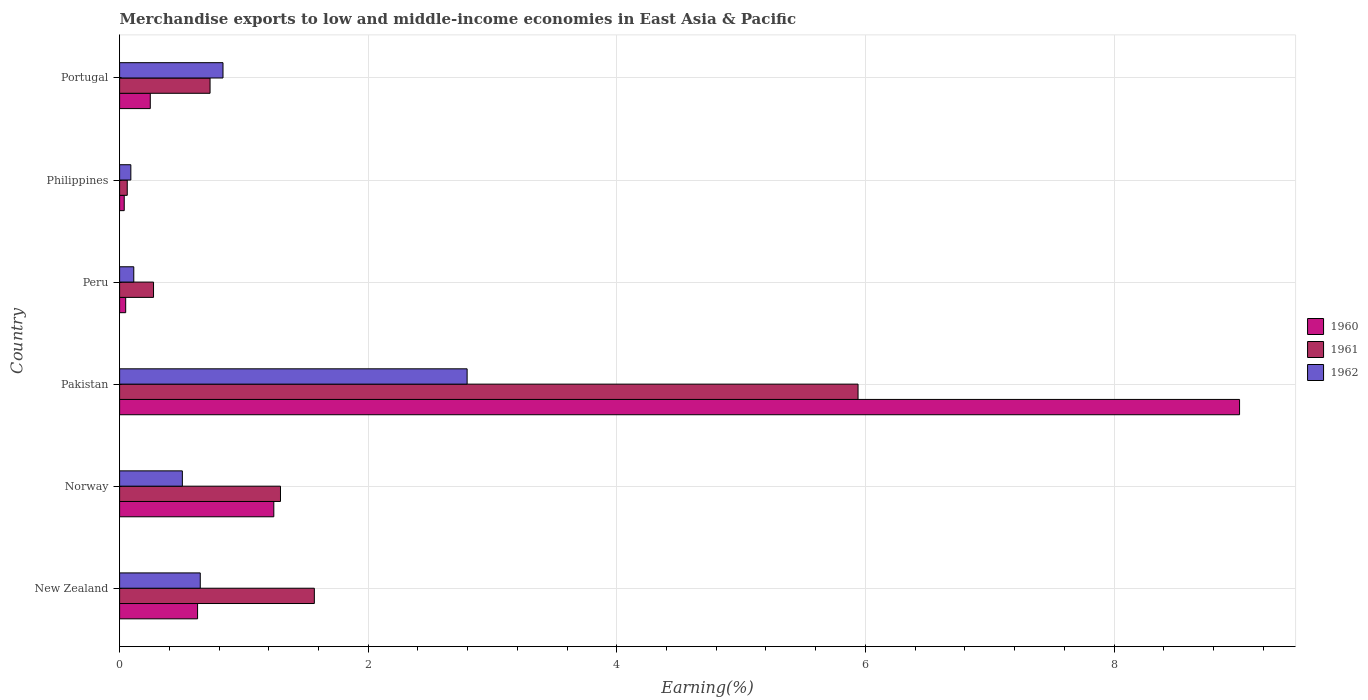How many groups of bars are there?
Give a very brief answer. 6. Are the number of bars on each tick of the Y-axis equal?
Offer a very short reply. Yes. How many bars are there on the 2nd tick from the bottom?
Give a very brief answer. 3. What is the label of the 1st group of bars from the top?
Your answer should be compact. Portugal. In how many cases, is the number of bars for a given country not equal to the number of legend labels?
Your response must be concise. 0. What is the percentage of amount earned from merchandise exports in 1960 in Philippines?
Offer a terse response. 0.04. Across all countries, what is the maximum percentage of amount earned from merchandise exports in 1960?
Provide a short and direct response. 9.01. Across all countries, what is the minimum percentage of amount earned from merchandise exports in 1960?
Provide a succinct answer. 0.04. In which country was the percentage of amount earned from merchandise exports in 1960 maximum?
Provide a short and direct response. Pakistan. In which country was the percentage of amount earned from merchandise exports in 1960 minimum?
Keep it short and to the point. Philippines. What is the total percentage of amount earned from merchandise exports in 1960 in the graph?
Offer a terse response. 11.21. What is the difference between the percentage of amount earned from merchandise exports in 1960 in Pakistan and that in Portugal?
Ensure brevity in your answer.  8.76. What is the difference between the percentage of amount earned from merchandise exports in 1960 in Norway and the percentage of amount earned from merchandise exports in 1961 in Portugal?
Offer a terse response. 0.51. What is the average percentage of amount earned from merchandise exports in 1961 per country?
Your response must be concise. 1.64. What is the difference between the percentage of amount earned from merchandise exports in 1961 and percentage of amount earned from merchandise exports in 1962 in Norway?
Your response must be concise. 0.79. What is the ratio of the percentage of amount earned from merchandise exports in 1961 in Pakistan to that in Peru?
Keep it short and to the point. 21.77. Is the percentage of amount earned from merchandise exports in 1961 in New Zealand less than that in Portugal?
Offer a terse response. No. Is the difference between the percentage of amount earned from merchandise exports in 1961 in Norway and Portugal greater than the difference between the percentage of amount earned from merchandise exports in 1962 in Norway and Portugal?
Your response must be concise. Yes. What is the difference between the highest and the second highest percentage of amount earned from merchandise exports in 1961?
Your response must be concise. 4.37. What is the difference between the highest and the lowest percentage of amount earned from merchandise exports in 1960?
Your response must be concise. 8.97. In how many countries, is the percentage of amount earned from merchandise exports in 1962 greater than the average percentage of amount earned from merchandise exports in 1962 taken over all countries?
Your response must be concise. 2. Is the sum of the percentage of amount earned from merchandise exports in 1960 in Peru and Philippines greater than the maximum percentage of amount earned from merchandise exports in 1962 across all countries?
Provide a succinct answer. No. What does the 1st bar from the top in Pakistan represents?
Provide a short and direct response. 1962. Is it the case that in every country, the sum of the percentage of amount earned from merchandise exports in 1961 and percentage of amount earned from merchandise exports in 1960 is greater than the percentage of amount earned from merchandise exports in 1962?
Give a very brief answer. Yes. How many countries are there in the graph?
Ensure brevity in your answer.  6. What is the difference between two consecutive major ticks on the X-axis?
Offer a very short reply. 2. Are the values on the major ticks of X-axis written in scientific E-notation?
Provide a short and direct response. No. What is the title of the graph?
Give a very brief answer. Merchandise exports to low and middle-income economies in East Asia & Pacific. Does "1985" appear as one of the legend labels in the graph?
Ensure brevity in your answer.  No. What is the label or title of the X-axis?
Your answer should be very brief. Earning(%). What is the label or title of the Y-axis?
Your answer should be compact. Country. What is the Earning(%) of 1960 in New Zealand?
Offer a terse response. 0.63. What is the Earning(%) in 1961 in New Zealand?
Offer a very short reply. 1.57. What is the Earning(%) in 1962 in New Zealand?
Provide a short and direct response. 0.65. What is the Earning(%) in 1960 in Norway?
Keep it short and to the point. 1.24. What is the Earning(%) in 1961 in Norway?
Provide a succinct answer. 1.29. What is the Earning(%) of 1962 in Norway?
Make the answer very short. 0.5. What is the Earning(%) in 1960 in Pakistan?
Provide a succinct answer. 9.01. What is the Earning(%) of 1961 in Pakistan?
Your answer should be compact. 5.94. What is the Earning(%) of 1962 in Pakistan?
Your answer should be very brief. 2.8. What is the Earning(%) in 1960 in Peru?
Provide a succinct answer. 0.05. What is the Earning(%) of 1961 in Peru?
Your answer should be very brief. 0.27. What is the Earning(%) of 1962 in Peru?
Your answer should be very brief. 0.11. What is the Earning(%) in 1960 in Philippines?
Ensure brevity in your answer.  0.04. What is the Earning(%) in 1961 in Philippines?
Make the answer very short. 0.06. What is the Earning(%) of 1962 in Philippines?
Give a very brief answer. 0.09. What is the Earning(%) of 1960 in Portugal?
Give a very brief answer. 0.25. What is the Earning(%) of 1961 in Portugal?
Offer a very short reply. 0.73. What is the Earning(%) of 1962 in Portugal?
Provide a succinct answer. 0.83. Across all countries, what is the maximum Earning(%) of 1960?
Your answer should be compact. 9.01. Across all countries, what is the maximum Earning(%) of 1961?
Make the answer very short. 5.94. Across all countries, what is the maximum Earning(%) of 1962?
Ensure brevity in your answer.  2.8. Across all countries, what is the minimum Earning(%) of 1960?
Give a very brief answer. 0.04. Across all countries, what is the minimum Earning(%) of 1961?
Offer a terse response. 0.06. Across all countries, what is the minimum Earning(%) in 1962?
Offer a terse response. 0.09. What is the total Earning(%) in 1960 in the graph?
Make the answer very short. 11.21. What is the total Earning(%) of 1961 in the graph?
Offer a terse response. 9.86. What is the total Earning(%) of 1962 in the graph?
Offer a terse response. 4.99. What is the difference between the Earning(%) in 1960 in New Zealand and that in Norway?
Give a very brief answer. -0.61. What is the difference between the Earning(%) of 1961 in New Zealand and that in Norway?
Your answer should be very brief. 0.27. What is the difference between the Earning(%) of 1962 in New Zealand and that in Norway?
Give a very brief answer. 0.14. What is the difference between the Earning(%) in 1960 in New Zealand and that in Pakistan?
Your response must be concise. -8.38. What is the difference between the Earning(%) of 1961 in New Zealand and that in Pakistan?
Provide a short and direct response. -4.37. What is the difference between the Earning(%) of 1962 in New Zealand and that in Pakistan?
Offer a terse response. -2.15. What is the difference between the Earning(%) in 1960 in New Zealand and that in Peru?
Your answer should be very brief. 0.58. What is the difference between the Earning(%) in 1961 in New Zealand and that in Peru?
Ensure brevity in your answer.  1.29. What is the difference between the Earning(%) in 1962 in New Zealand and that in Peru?
Provide a short and direct response. 0.53. What is the difference between the Earning(%) in 1960 in New Zealand and that in Philippines?
Your answer should be compact. 0.59. What is the difference between the Earning(%) in 1961 in New Zealand and that in Philippines?
Give a very brief answer. 1.51. What is the difference between the Earning(%) of 1962 in New Zealand and that in Philippines?
Provide a short and direct response. 0.56. What is the difference between the Earning(%) in 1960 in New Zealand and that in Portugal?
Make the answer very short. 0.38. What is the difference between the Earning(%) in 1961 in New Zealand and that in Portugal?
Offer a very short reply. 0.84. What is the difference between the Earning(%) of 1962 in New Zealand and that in Portugal?
Ensure brevity in your answer.  -0.18. What is the difference between the Earning(%) in 1960 in Norway and that in Pakistan?
Offer a terse response. -7.77. What is the difference between the Earning(%) in 1961 in Norway and that in Pakistan?
Ensure brevity in your answer.  -4.65. What is the difference between the Earning(%) in 1962 in Norway and that in Pakistan?
Your response must be concise. -2.29. What is the difference between the Earning(%) in 1960 in Norway and that in Peru?
Offer a terse response. 1.19. What is the difference between the Earning(%) of 1961 in Norway and that in Peru?
Keep it short and to the point. 1.02. What is the difference between the Earning(%) in 1962 in Norway and that in Peru?
Your answer should be very brief. 0.39. What is the difference between the Earning(%) in 1960 in Norway and that in Philippines?
Your answer should be very brief. 1.2. What is the difference between the Earning(%) in 1961 in Norway and that in Philippines?
Provide a succinct answer. 1.23. What is the difference between the Earning(%) of 1962 in Norway and that in Philippines?
Make the answer very short. 0.41. What is the difference between the Earning(%) of 1961 in Norway and that in Portugal?
Provide a succinct answer. 0.57. What is the difference between the Earning(%) in 1962 in Norway and that in Portugal?
Make the answer very short. -0.33. What is the difference between the Earning(%) of 1960 in Pakistan and that in Peru?
Your answer should be compact. 8.96. What is the difference between the Earning(%) in 1961 in Pakistan and that in Peru?
Provide a short and direct response. 5.67. What is the difference between the Earning(%) in 1962 in Pakistan and that in Peru?
Keep it short and to the point. 2.68. What is the difference between the Earning(%) in 1960 in Pakistan and that in Philippines?
Give a very brief answer. 8.97. What is the difference between the Earning(%) in 1961 in Pakistan and that in Philippines?
Give a very brief answer. 5.88. What is the difference between the Earning(%) of 1962 in Pakistan and that in Philippines?
Your answer should be compact. 2.71. What is the difference between the Earning(%) of 1960 in Pakistan and that in Portugal?
Your answer should be compact. 8.76. What is the difference between the Earning(%) in 1961 in Pakistan and that in Portugal?
Make the answer very short. 5.21. What is the difference between the Earning(%) in 1962 in Pakistan and that in Portugal?
Provide a short and direct response. 1.96. What is the difference between the Earning(%) in 1960 in Peru and that in Philippines?
Your answer should be compact. 0.01. What is the difference between the Earning(%) in 1961 in Peru and that in Philippines?
Provide a short and direct response. 0.21. What is the difference between the Earning(%) of 1962 in Peru and that in Philippines?
Provide a short and direct response. 0.02. What is the difference between the Earning(%) of 1960 in Peru and that in Portugal?
Offer a very short reply. -0.2. What is the difference between the Earning(%) of 1961 in Peru and that in Portugal?
Offer a terse response. -0.45. What is the difference between the Earning(%) of 1962 in Peru and that in Portugal?
Make the answer very short. -0.72. What is the difference between the Earning(%) in 1960 in Philippines and that in Portugal?
Ensure brevity in your answer.  -0.21. What is the difference between the Earning(%) in 1961 in Philippines and that in Portugal?
Your response must be concise. -0.67. What is the difference between the Earning(%) of 1962 in Philippines and that in Portugal?
Provide a short and direct response. -0.74. What is the difference between the Earning(%) in 1960 in New Zealand and the Earning(%) in 1961 in Norway?
Offer a very short reply. -0.67. What is the difference between the Earning(%) in 1960 in New Zealand and the Earning(%) in 1962 in Norway?
Provide a short and direct response. 0.12. What is the difference between the Earning(%) in 1961 in New Zealand and the Earning(%) in 1962 in Norway?
Your response must be concise. 1.06. What is the difference between the Earning(%) in 1960 in New Zealand and the Earning(%) in 1961 in Pakistan?
Make the answer very short. -5.31. What is the difference between the Earning(%) in 1960 in New Zealand and the Earning(%) in 1962 in Pakistan?
Give a very brief answer. -2.17. What is the difference between the Earning(%) in 1961 in New Zealand and the Earning(%) in 1962 in Pakistan?
Give a very brief answer. -1.23. What is the difference between the Earning(%) of 1960 in New Zealand and the Earning(%) of 1961 in Peru?
Make the answer very short. 0.35. What is the difference between the Earning(%) in 1960 in New Zealand and the Earning(%) in 1962 in Peru?
Your answer should be very brief. 0.51. What is the difference between the Earning(%) of 1961 in New Zealand and the Earning(%) of 1962 in Peru?
Your answer should be compact. 1.45. What is the difference between the Earning(%) in 1960 in New Zealand and the Earning(%) in 1961 in Philippines?
Your answer should be compact. 0.57. What is the difference between the Earning(%) in 1960 in New Zealand and the Earning(%) in 1962 in Philippines?
Make the answer very short. 0.54. What is the difference between the Earning(%) in 1961 in New Zealand and the Earning(%) in 1962 in Philippines?
Give a very brief answer. 1.48. What is the difference between the Earning(%) of 1960 in New Zealand and the Earning(%) of 1961 in Portugal?
Your response must be concise. -0.1. What is the difference between the Earning(%) of 1960 in New Zealand and the Earning(%) of 1962 in Portugal?
Offer a very short reply. -0.2. What is the difference between the Earning(%) of 1961 in New Zealand and the Earning(%) of 1962 in Portugal?
Offer a terse response. 0.73. What is the difference between the Earning(%) in 1960 in Norway and the Earning(%) in 1961 in Pakistan?
Provide a short and direct response. -4.7. What is the difference between the Earning(%) in 1960 in Norway and the Earning(%) in 1962 in Pakistan?
Offer a very short reply. -1.56. What is the difference between the Earning(%) of 1961 in Norway and the Earning(%) of 1962 in Pakistan?
Offer a terse response. -1.5. What is the difference between the Earning(%) in 1960 in Norway and the Earning(%) in 1962 in Peru?
Your answer should be very brief. 1.13. What is the difference between the Earning(%) in 1961 in Norway and the Earning(%) in 1962 in Peru?
Offer a very short reply. 1.18. What is the difference between the Earning(%) of 1960 in Norway and the Earning(%) of 1961 in Philippines?
Offer a terse response. 1.18. What is the difference between the Earning(%) in 1960 in Norway and the Earning(%) in 1962 in Philippines?
Your answer should be compact. 1.15. What is the difference between the Earning(%) of 1961 in Norway and the Earning(%) of 1962 in Philippines?
Offer a terse response. 1.2. What is the difference between the Earning(%) of 1960 in Norway and the Earning(%) of 1961 in Portugal?
Keep it short and to the point. 0.51. What is the difference between the Earning(%) in 1960 in Norway and the Earning(%) in 1962 in Portugal?
Your answer should be very brief. 0.41. What is the difference between the Earning(%) in 1961 in Norway and the Earning(%) in 1962 in Portugal?
Provide a succinct answer. 0.46. What is the difference between the Earning(%) in 1960 in Pakistan and the Earning(%) in 1961 in Peru?
Your response must be concise. 8.74. What is the difference between the Earning(%) of 1960 in Pakistan and the Earning(%) of 1962 in Peru?
Your answer should be compact. 8.9. What is the difference between the Earning(%) of 1961 in Pakistan and the Earning(%) of 1962 in Peru?
Your answer should be compact. 5.83. What is the difference between the Earning(%) of 1960 in Pakistan and the Earning(%) of 1961 in Philippines?
Keep it short and to the point. 8.95. What is the difference between the Earning(%) in 1960 in Pakistan and the Earning(%) in 1962 in Philippines?
Give a very brief answer. 8.92. What is the difference between the Earning(%) in 1961 in Pakistan and the Earning(%) in 1962 in Philippines?
Offer a very short reply. 5.85. What is the difference between the Earning(%) of 1960 in Pakistan and the Earning(%) of 1961 in Portugal?
Provide a short and direct response. 8.28. What is the difference between the Earning(%) in 1960 in Pakistan and the Earning(%) in 1962 in Portugal?
Provide a short and direct response. 8.18. What is the difference between the Earning(%) in 1961 in Pakistan and the Earning(%) in 1962 in Portugal?
Keep it short and to the point. 5.11. What is the difference between the Earning(%) in 1960 in Peru and the Earning(%) in 1961 in Philippines?
Ensure brevity in your answer.  -0.01. What is the difference between the Earning(%) in 1960 in Peru and the Earning(%) in 1962 in Philippines?
Keep it short and to the point. -0.04. What is the difference between the Earning(%) in 1961 in Peru and the Earning(%) in 1962 in Philippines?
Provide a succinct answer. 0.18. What is the difference between the Earning(%) in 1960 in Peru and the Earning(%) in 1961 in Portugal?
Keep it short and to the point. -0.68. What is the difference between the Earning(%) in 1960 in Peru and the Earning(%) in 1962 in Portugal?
Offer a terse response. -0.78. What is the difference between the Earning(%) in 1961 in Peru and the Earning(%) in 1962 in Portugal?
Your response must be concise. -0.56. What is the difference between the Earning(%) in 1960 in Philippines and the Earning(%) in 1961 in Portugal?
Provide a succinct answer. -0.69. What is the difference between the Earning(%) of 1960 in Philippines and the Earning(%) of 1962 in Portugal?
Make the answer very short. -0.79. What is the difference between the Earning(%) in 1961 in Philippines and the Earning(%) in 1962 in Portugal?
Give a very brief answer. -0.77. What is the average Earning(%) in 1960 per country?
Offer a very short reply. 1.87. What is the average Earning(%) in 1961 per country?
Your response must be concise. 1.64. What is the average Earning(%) in 1962 per country?
Your answer should be very brief. 0.83. What is the difference between the Earning(%) of 1960 and Earning(%) of 1961 in New Zealand?
Your answer should be compact. -0.94. What is the difference between the Earning(%) in 1960 and Earning(%) in 1962 in New Zealand?
Give a very brief answer. -0.02. What is the difference between the Earning(%) in 1961 and Earning(%) in 1962 in New Zealand?
Give a very brief answer. 0.92. What is the difference between the Earning(%) of 1960 and Earning(%) of 1961 in Norway?
Give a very brief answer. -0.05. What is the difference between the Earning(%) of 1960 and Earning(%) of 1962 in Norway?
Your answer should be compact. 0.74. What is the difference between the Earning(%) of 1961 and Earning(%) of 1962 in Norway?
Make the answer very short. 0.79. What is the difference between the Earning(%) in 1960 and Earning(%) in 1961 in Pakistan?
Give a very brief answer. 3.07. What is the difference between the Earning(%) of 1960 and Earning(%) of 1962 in Pakistan?
Ensure brevity in your answer.  6.21. What is the difference between the Earning(%) in 1961 and Earning(%) in 1962 in Pakistan?
Provide a short and direct response. 3.14. What is the difference between the Earning(%) in 1960 and Earning(%) in 1961 in Peru?
Offer a very short reply. -0.22. What is the difference between the Earning(%) in 1960 and Earning(%) in 1962 in Peru?
Provide a short and direct response. -0.07. What is the difference between the Earning(%) of 1961 and Earning(%) of 1962 in Peru?
Ensure brevity in your answer.  0.16. What is the difference between the Earning(%) of 1960 and Earning(%) of 1961 in Philippines?
Offer a terse response. -0.02. What is the difference between the Earning(%) of 1960 and Earning(%) of 1962 in Philippines?
Your answer should be compact. -0.05. What is the difference between the Earning(%) of 1961 and Earning(%) of 1962 in Philippines?
Ensure brevity in your answer.  -0.03. What is the difference between the Earning(%) of 1960 and Earning(%) of 1961 in Portugal?
Your answer should be very brief. -0.48. What is the difference between the Earning(%) in 1960 and Earning(%) in 1962 in Portugal?
Keep it short and to the point. -0.58. What is the difference between the Earning(%) in 1961 and Earning(%) in 1962 in Portugal?
Your response must be concise. -0.1. What is the ratio of the Earning(%) in 1960 in New Zealand to that in Norway?
Your answer should be very brief. 0.51. What is the ratio of the Earning(%) in 1961 in New Zealand to that in Norway?
Ensure brevity in your answer.  1.21. What is the ratio of the Earning(%) of 1962 in New Zealand to that in Norway?
Offer a very short reply. 1.29. What is the ratio of the Earning(%) in 1960 in New Zealand to that in Pakistan?
Offer a very short reply. 0.07. What is the ratio of the Earning(%) of 1961 in New Zealand to that in Pakistan?
Your response must be concise. 0.26. What is the ratio of the Earning(%) of 1962 in New Zealand to that in Pakistan?
Give a very brief answer. 0.23. What is the ratio of the Earning(%) in 1960 in New Zealand to that in Peru?
Provide a succinct answer. 12.82. What is the ratio of the Earning(%) in 1961 in New Zealand to that in Peru?
Provide a short and direct response. 5.74. What is the ratio of the Earning(%) in 1962 in New Zealand to that in Peru?
Make the answer very short. 5.69. What is the ratio of the Earning(%) of 1960 in New Zealand to that in Philippines?
Give a very brief answer. 16.84. What is the ratio of the Earning(%) of 1961 in New Zealand to that in Philippines?
Offer a very short reply. 25.46. What is the ratio of the Earning(%) in 1962 in New Zealand to that in Philippines?
Offer a very short reply. 7.18. What is the ratio of the Earning(%) of 1960 in New Zealand to that in Portugal?
Ensure brevity in your answer.  2.54. What is the ratio of the Earning(%) of 1961 in New Zealand to that in Portugal?
Offer a very short reply. 2.15. What is the ratio of the Earning(%) of 1962 in New Zealand to that in Portugal?
Your answer should be compact. 0.78. What is the ratio of the Earning(%) in 1960 in Norway to that in Pakistan?
Your response must be concise. 0.14. What is the ratio of the Earning(%) in 1961 in Norway to that in Pakistan?
Your response must be concise. 0.22. What is the ratio of the Earning(%) of 1962 in Norway to that in Pakistan?
Your answer should be very brief. 0.18. What is the ratio of the Earning(%) in 1960 in Norway to that in Peru?
Offer a very short reply. 25.36. What is the ratio of the Earning(%) of 1961 in Norway to that in Peru?
Give a very brief answer. 4.74. What is the ratio of the Earning(%) in 1962 in Norway to that in Peru?
Offer a terse response. 4.42. What is the ratio of the Earning(%) in 1960 in Norway to that in Philippines?
Ensure brevity in your answer.  33.31. What is the ratio of the Earning(%) of 1961 in Norway to that in Philippines?
Ensure brevity in your answer.  21.03. What is the ratio of the Earning(%) of 1962 in Norway to that in Philippines?
Give a very brief answer. 5.59. What is the ratio of the Earning(%) of 1960 in Norway to that in Portugal?
Your answer should be very brief. 5.03. What is the ratio of the Earning(%) in 1961 in Norway to that in Portugal?
Give a very brief answer. 1.78. What is the ratio of the Earning(%) in 1962 in Norway to that in Portugal?
Give a very brief answer. 0.61. What is the ratio of the Earning(%) in 1960 in Pakistan to that in Peru?
Your answer should be very brief. 184.16. What is the ratio of the Earning(%) in 1961 in Pakistan to that in Peru?
Offer a very short reply. 21.77. What is the ratio of the Earning(%) in 1962 in Pakistan to that in Peru?
Your response must be concise. 24.5. What is the ratio of the Earning(%) in 1960 in Pakistan to that in Philippines?
Ensure brevity in your answer.  241.91. What is the ratio of the Earning(%) in 1961 in Pakistan to that in Philippines?
Keep it short and to the point. 96.53. What is the ratio of the Earning(%) of 1962 in Pakistan to that in Philippines?
Keep it short and to the point. 30.93. What is the ratio of the Earning(%) of 1960 in Pakistan to that in Portugal?
Make the answer very short. 36.51. What is the ratio of the Earning(%) in 1961 in Pakistan to that in Portugal?
Offer a very short reply. 8.16. What is the ratio of the Earning(%) in 1962 in Pakistan to that in Portugal?
Keep it short and to the point. 3.36. What is the ratio of the Earning(%) of 1960 in Peru to that in Philippines?
Provide a succinct answer. 1.31. What is the ratio of the Earning(%) in 1961 in Peru to that in Philippines?
Provide a short and direct response. 4.44. What is the ratio of the Earning(%) in 1962 in Peru to that in Philippines?
Make the answer very short. 1.26. What is the ratio of the Earning(%) of 1960 in Peru to that in Portugal?
Your answer should be compact. 0.2. What is the ratio of the Earning(%) in 1961 in Peru to that in Portugal?
Provide a succinct answer. 0.38. What is the ratio of the Earning(%) of 1962 in Peru to that in Portugal?
Make the answer very short. 0.14. What is the ratio of the Earning(%) in 1960 in Philippines to that in Portugal?
Ensure brevity in your answer.  0.15. What is the ratio of the Earning(%) in 1961 in Philippines to that in Portugal?
Offer a terse response. 0.08. What is the ratio of the Earning(%) in 1962 in Philippines to that in Portugal?
Ensure brevity in your answer.  0.11. What is the difference between the highest and the second highest Earning(%) in 1960?
Provide a succinct answer. 7.77. What is the difference between the highest and the second highest Earning(%) of 1961?
Keep it short and to the point. 4.37. What is the difference between the highest and the second highest Earning(%) of 1962?
Your answer should be very brief. 1.96. What is the difference between the highest and the lowest Earning(%) in 1960?
Provide a succinct answer. 8.97. What is the difference between the highest and the lowest Earning(%) of 1961?
Keep it short and to the point. 5.88. What is the difference between the highest and the lowest Earning(%) of 1962?
Provide a succinct answer. 2.71. 